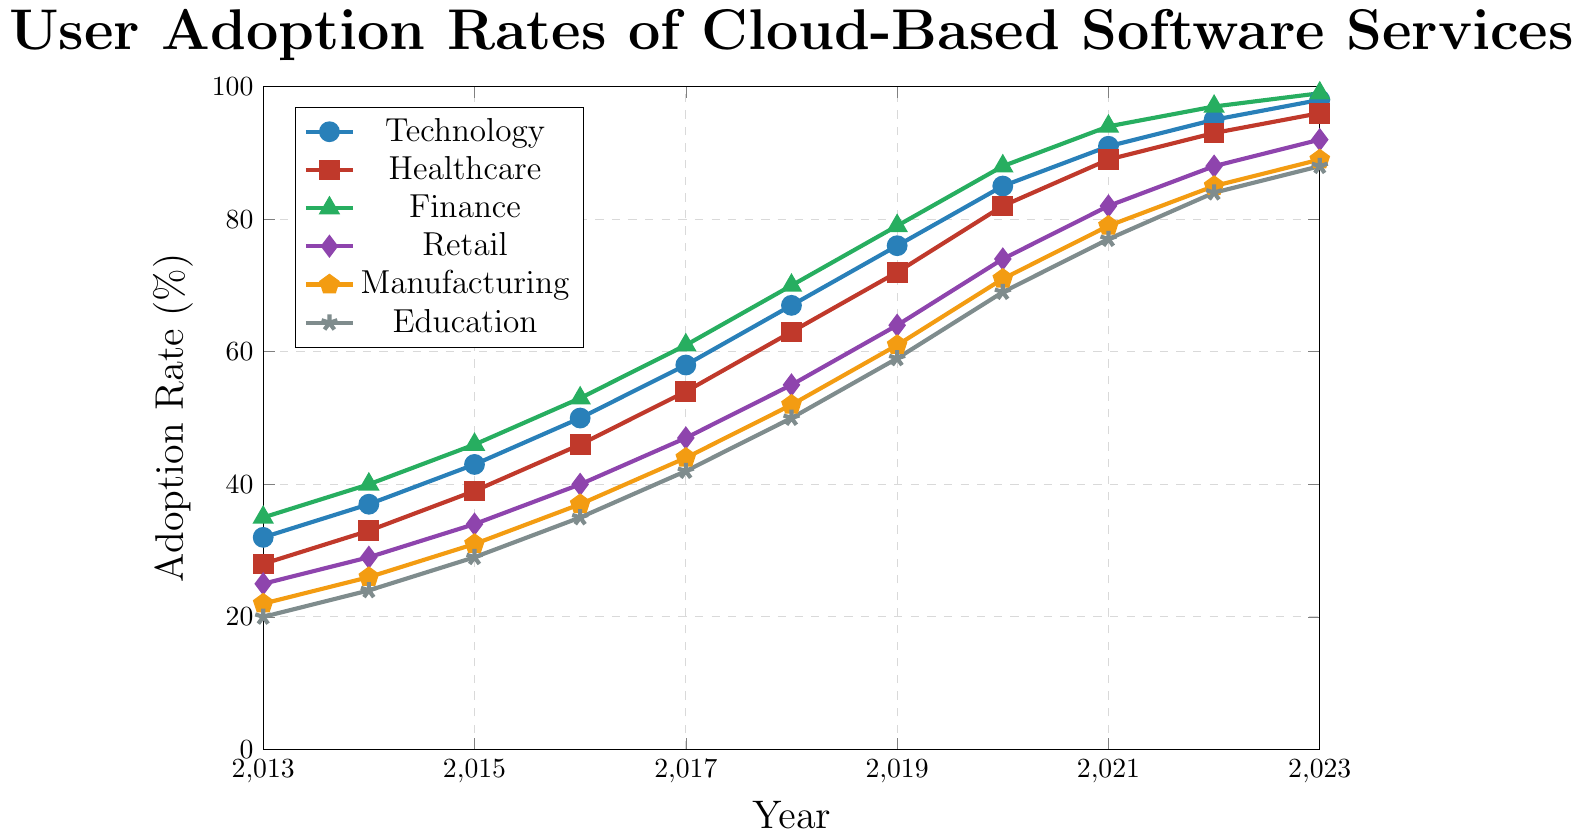What industry saw the highest adoption rate in 2023? The adoption rates in 2023 for each sector are visible on the far right of the plot. Technology stands at 98%, Healthcare at 96%, Finance at 99%, Retail at 92%, Manufacturing at 89%, and Education at 88%. Therefore, the Finance sector saw the highest adoption rate in 2023.
Answer: Finance Which two sectors had the smallest difference in adoption rates in 2016? Date points for 2016 are shown on the plot. The adoption rates are: Technology (50%), Healthcare (46%), Finance (53%), Retail (40%), Manufacturing (37%), and Education (35%). The closest numbers are 37% for Manufacturing and 35% for Education, creating a difference of 2%.
Answer: Manufacturing and Education What was the average adoption rate of Technology and Finance sectors in 2020? In 2020, the adoption rate for Technology was 85%, and for Finance, it was 88%. To find the average: (85 + 88)/2 = 86.5%.
Answer: 86.5% Which sector had the fastest growth rate in adoption from 2013 to 2023? Compare the adoption rate increase from 2013 to 2023 for each sector. Technology: 98% - 32% = 66%, Healthcare: 96% - 28% = 68%, Finance: 99% - 35% = 64%, Retail: 92% - 25% = 67%, Manufacturing: 89% - 22% = 67%, Education: 88% - 20% = 68%. Healthcare and Education had the highest increase, both 68%.
Answer: Healthcare and Education Which two sectors exhibited similar growth trends over the decade? Visually, Healthcare and Finance show nearly parallel lines, indicating similar growth trends over the decade. Both have steep upward trends that are comparable in shape and rate of increase.
Answer: Healthcare and Finance What was the overall trend in cloud service adoption across all sectors from 2013 to 2023? Examining the trajectories of all the curves from left (2013) to right (2023) on the plot, all sectors show consistent and notable upward trends, indicating a significant increase in cloud service adoption across all sectors.
Answer: Upward In what year did Healthcare surpass the 50% adoption rate? To determine the year in which Healthcare surpassed 50%, look for the first data point above 50% on its line: In 2016, Healthcare reaches 46%, and in 2017 it climbs to 54%. Therefore, Healthcare surpassed 50% in 2017.
Answer: 2017 By how many percentage points did the adoption rate for Retail change from 2019 to 2023? In 2019, Retail had a 64% adoption rate and in 2023 it had 92%. The difference is 92% - 64% = 28%.
Answer: 28% Which sector had the lowest adoption rate in 2015 and what was it? Review the adoption rates for each sector in 2015. Technology (43%), Healthcare (39%), Finance (46%), Retail (34%), Manufacturing (31%), and Education (29%): The lowest adoption rate was 29% in Education.
Answer: Education, 29% 